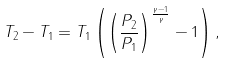Convert formula to latex. <formula><loc_0><loc_0><loc_500><loc_500>T _ { 2 } - T _ { 1 } = T _ { 1 } \left ( \left ( { \frac { P _ { 2 } } { P _ { 1 } } } \right ) ^ { \frac { \gamma - 1 } { \gamma } } - 1 \right ) ,</formula> 